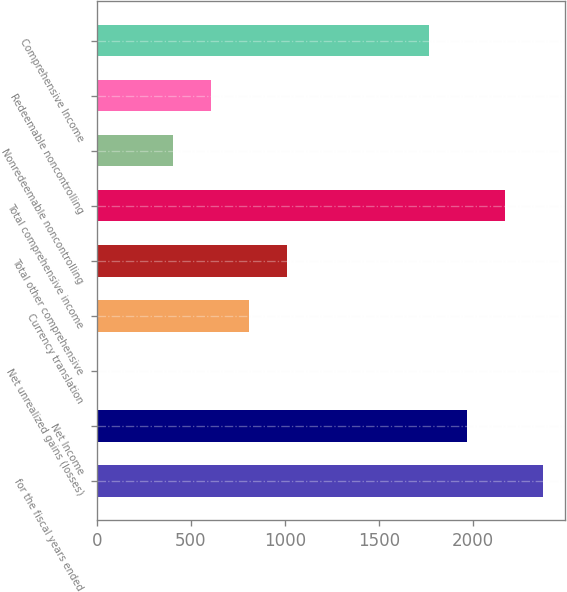Convert chart. <chart><loc_0><loc_0><loc_500><loc_500><bar_chart><fcel>for the fiscal years ended<fcel>Net Income<fcel>Net unrealized gains (losses)<fcel>Currency translation<fcel>Total other comprehensive<fcel>Total comprehensive income<fcel>Nonredeemable noncontrolling<fcel>Redeemable noncontrolling<fcel>Comprehensive Income<nl><fcel>2370.87<fcel>1967.89<fcel>2.1<fcel>808.06<fcel>1009.55<fcel>2169.38<fcel>405.08<fcel>606.57<fcel>1766.4<nl></chart> 